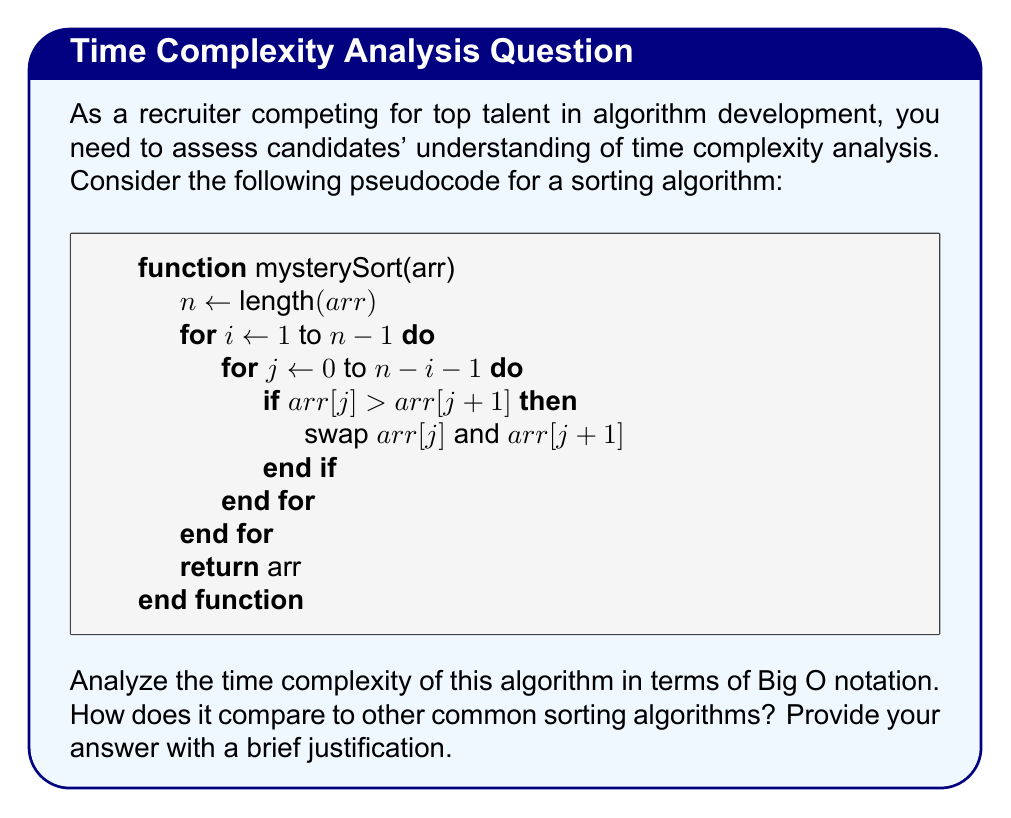Show me your answer to this math problem. To analyze the time complexity of this algorithm, let's break it down step-by-step:

1. Identify the nested loops:
   - The outer loop runs from $i = 1$ to $n-1$, where $n$ is the length of the array.
   - The inner loop runs from $j = 0$ to $n-i-1$ for each iteration of the outer loop.

2. Count the number of comparisons:
   - In the first iteration of the outer loop, the inner loop runs $n-1$ times.
   - In the second iteration, it runs $n-2$ times.
   - This continues until the last iteration, where it runs once.

3. Sum up the total number of comparisons:
   $$(n-1) + (n-2) + (n-3) + ... + 2 + 1$$
   This is an arithmetic series with $n-1$ terms.

4. Calculate the sum of the arithmetic series:
   $$S = \frac{n(n-1)}{2}$$

5. Analyze the Big O complexity:
   - The dominant term is $n^2$
   - Therefore, the time complexity is $O(n^2)$

6. Compare with other sorting algorithms:
   - This algorithm has the same time complexity as Bubble Sort.
   - It's less efficient than more advanced algorithms like Merge Sort or Quick Sort, which have average-case time complexities of $O(n \log n)$.

7. Justify the answer:
   - The nested loops result in a quadratic time complexity.
   - For each element, we potentially compare and swap with every other element.
   - This leads to inefficiency for large datasets compared to more optimized sorting algorithms.
Answer: $O(n^2)$, quadratic time complexity similar to Bubble Sort, less efficient than $O(n \log n)$ algorithms like Merge Sort or Quick Sort for large datasets. 